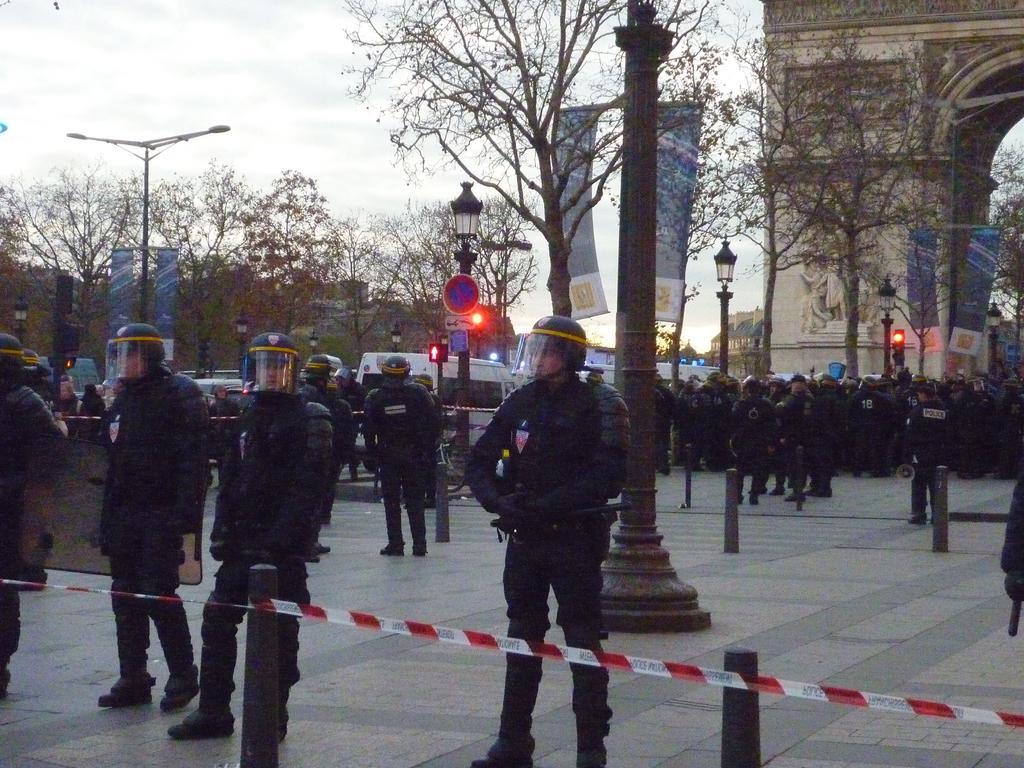Describe this image in one or two sentences. Here we can see group of people, poles, boards, traffic signals, banners, vehicles, trees, and buildings. In the background there is sky. 